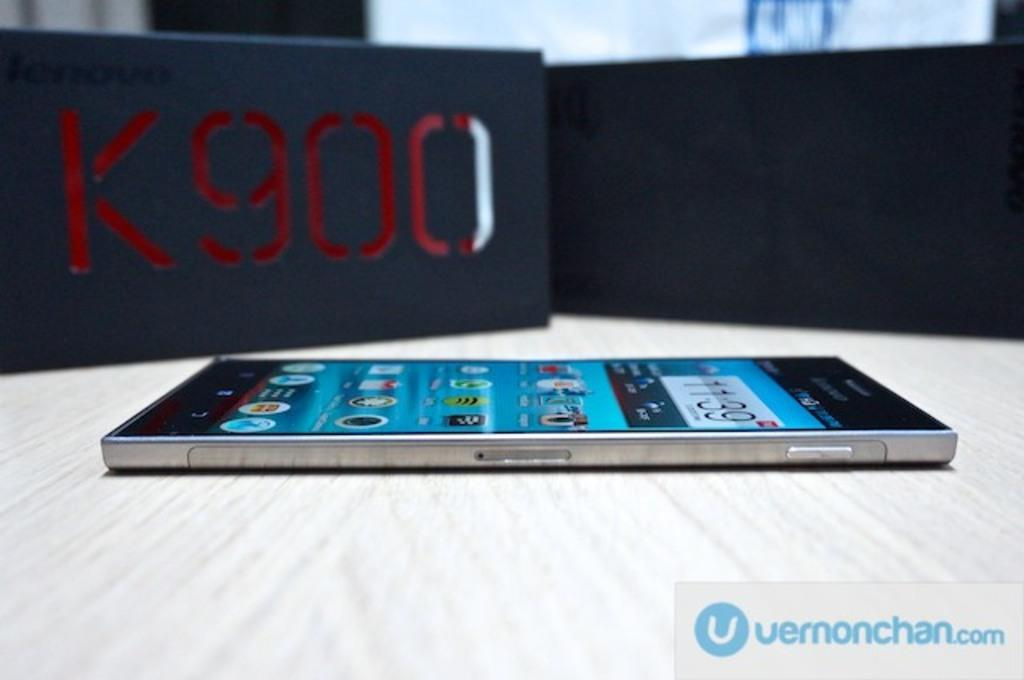Provide a one-sentence caption for the provided image. A smart phone rests on a surface next to a K900 box. 